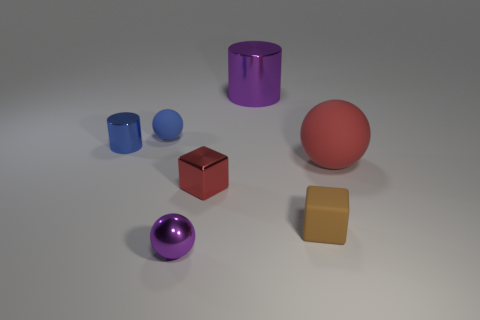What material is the object that is to the right of the small metal block and to the left of the tiny brown object?
Your answer should be very brief. Metal. There is a matte thing that is behind the big red ball; is it the same shape as the large object that is in front of the tiny blue matte thing?
Make the answer very short. Yes. There is a red object that is to the right of the big object to the left of the ball that is to the right of the small purple thing; what is its shape?
Offer a very short reply. Sphere. How many other things are there of the same shape as the tiny purple metallic thing?
Offer a terse response. 2. What color is the cylinder that is the same size as the blue matte ball?
Give a very brief answer. Blue. How many balls are purple things or tiny gray metallic objects?
Provide a short and direct response. 1. How many blue metallic things are there?
Keep it short and to the point. 1. There is a big rubber object; is its shape the same as the purple thing behind the metal cube?
Give a very brief answer. No. What size is the cylinder that is the same color as the small metal sphere?
Your answer should be compact. Large. What number of objects are small blue shiny cylinders or big cyan cubes?
Make the answer very short. 1. 